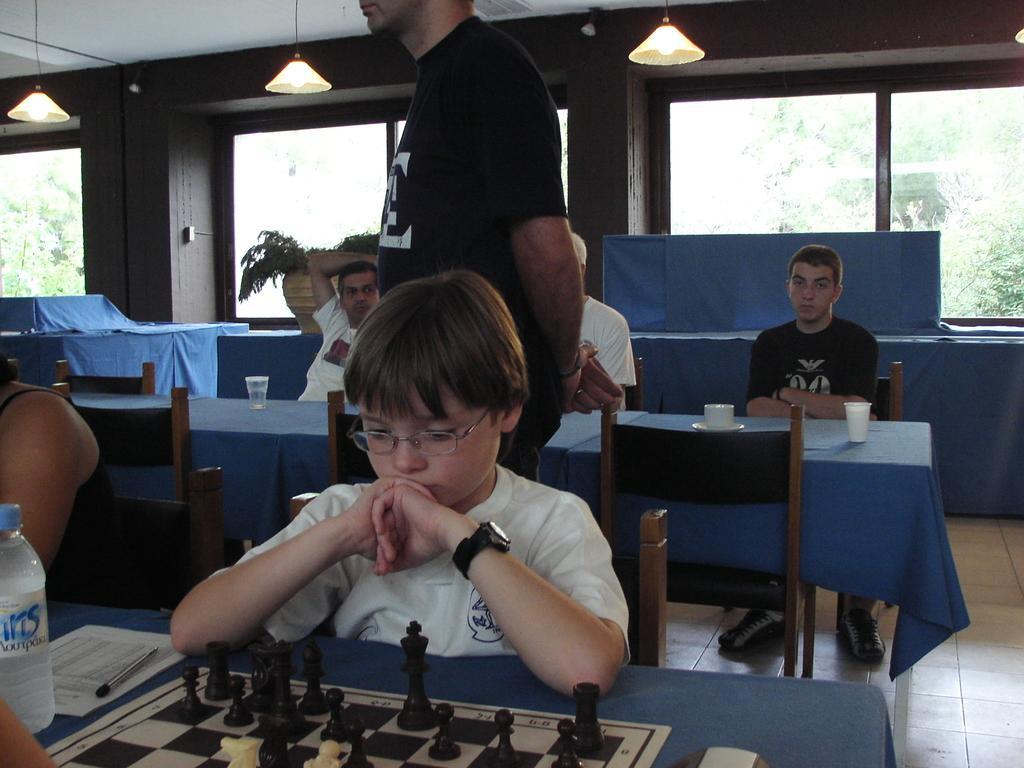Please provide a concise description of this image. In this image, There is a table on that there is a chess board, and a boy is sitting on the chair, In the background there are some people sitting on the chair and a man is standing behind the boy and there is a wall of brown color and on the top the lights are hanging. 